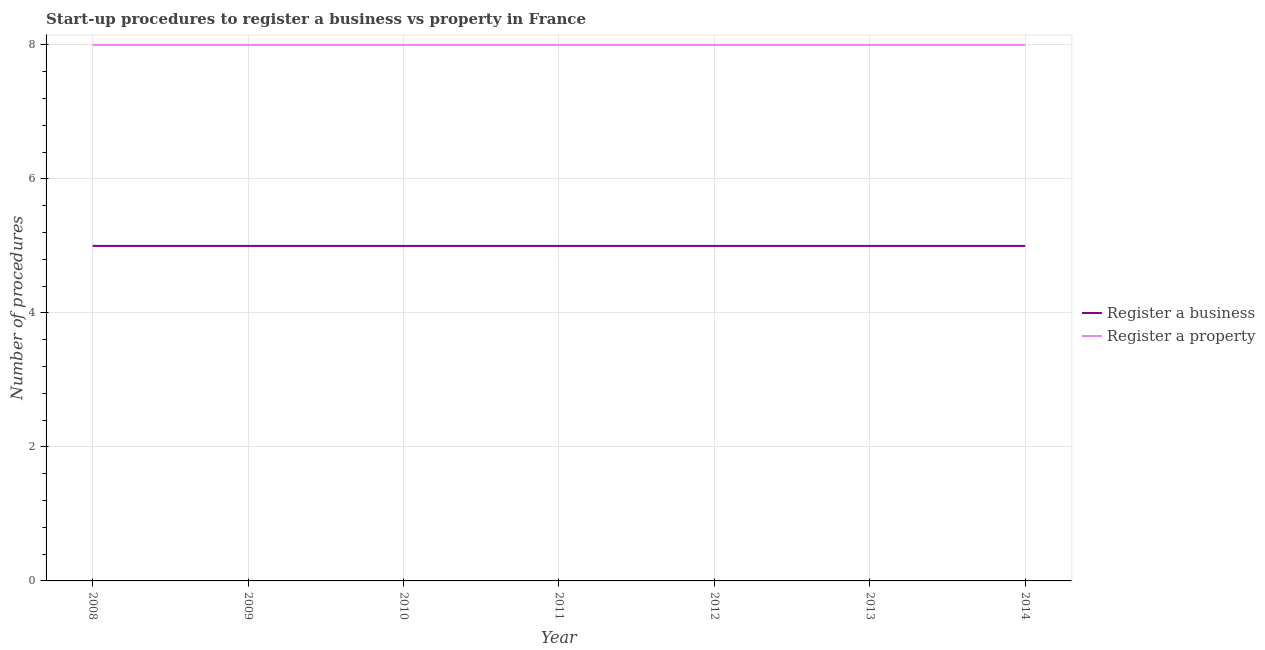Does the line corresponding to number of procedures to register a business intersect with the line corresponding to number of procedures to register a property?
Offer a very short reply. No. Is the number of lines equal to the number of legend labels?
Give a very brief answer. Yes. What is the number of procedures to register a property in 2014?
Offer a very short reply. 8. Across all years, what is the maximum number of procedures to register a property?
Give a very brief answer. 8. Across all years, what is the minimum number of procedures to register a property?
Your answer should be very brief. 8. In which year was the number of procedures to register a business maximum?
Provide a succinct answer. 2008. What is the total number of procedures to register a property in the graph?
Your answer should be very brief. 56. What is the difference between the number of procedures to register a business in 2010 and that in 2014?
Provide a short and direct response. 0. What is the difference between the number of procedures to register a business in 2013 and the number of procedures to register a property in 2014?
Make the answer very short. -3. In the year 2014, what is the difference between the number of procedures to register a business and number of procedures to register a property?
Ensure brevity in your answer.  -3. What is the ratio of the number of procedures to register a business in 2009 to that in 2011?
Ensure brevity in your answer.  1. Is the number of procedures to register a business in 2008 less than that in 2012?
Give a very brief answer. No. In how many years, is the number of procedures to register a property greater than the average number of procedures to register a property taken over all years?
Make the answer very short. 0. Is the sum of the number of procedures to register a business in 2009 and 2012 greater than the maximum number of procedures to register a property across all years?
Ensure brevity in your answer.  Yes. Does the number of procedures to register a property monotonically increase over the years?
Offer a terse response. No. Is the number of procedures to register a business strictly less than the number of procedures to register a property over the years?
Offer a very short reply. Yes. How many lines are there?
Offer a terse response. 2. How many years are there in the graph?
Give a very brief answer. 7. What is the difference between two consecutive major ticks on the Y-axis?
Make the answer very short. 2. Are the values on the major ticks of Y-axis written in scientific E-notation?
Offer a very short reply. No. Does the graph contain any zero values?
Provide a succinct answer. No. Where does the legend appear in the graph?
Offer a terse response. Center right. What is the title of the graph?
Ensure brevity in your answer.  Start-up procedures to register a business vs property in France. Does "Investment" appear as one of the legend labels in the graph?
Give a very brief answer. No. What is the label or title of the X-axis?
Ensure brevity in your answer.  Year. What is the label or title of the Y-axis?
Keep it short and to the point. Number of procedures. What is the Number of procedures in Register a business in 2008?
Your answer should be compact. 5. What is the Number of procedures of Register a property in 2008?
Give a very brief answer. 8. What is the Number of procedures of Register a business in 2009?
Provide a succinct answer. 5. What is the Number of procedures of Register a property in 2009?
Your answer should be compact. 8. What is the Number of procedures of Register a business in 2011?
Keep it short and to the point. 5. What is the Number of procedures of Register a property in 2011?
Give a very brief answer. 8. What is the Number of procedures of Register a business in 2012?
Keep it short and to the point. 5. What is the Number of procedures of Register a business in 2014?
Provide a short and direct response. 5. What is the total Number of procedures in Register a business in the graph?
Provide a short and direct response. 35. What is the total Number of procedures of Register a property in the graph?
Provide a succinct answer. 56. What is the difference between the Number of procedures of Register a business in 2008 and that in 2010?
Ensure brevity in your answer.  0. What is the difference between the Number of procedures of Register a property in 2008 and that in 2011?
Offer a very short reply. 0. What is the difference between the Number of procedures in Register a business in 2008 and that in 2012?
Ensure brevity in your answer.  0. What is the difference between the Number of procedures of Register a business in 2008 and that in 2013?
Keep it short and to the point. 0. What is the difference between the Number of procedures of Register a business in 2009 and that in 2011?
Provide a succinct answer. 0. What is the difference between the Number of procedures of Register a business in 2009 and that in 2013?
Provide a short and direct response. 0. What is the difference between the Number of procedures of Register a property in 2009 and that in 2013?
Provide a succinct answer. 0. What is the difference between the Number of procedures in Register a business in 2009 and that in 2014?
Provide a succinct answer. 0. What is the difference between the Number of procedures of Register a business in 2010 and that in 2011?
Give a very brief answer. 0. What is the difference between the Number of procedures of Register a business in 2010 and that in 2012?
Provide a short and direct response. 0. What is the difference between the Number of procedures in Register a property in 2010 and that in 2012?
Offer a very short reply. 0. What is the difference between the Number of procedures in Register a business in 2010 and that in 2013?
Provide a short and direct response. 0. What is the difference between the Number of procedures in Register a property in 2010 and that in 2013?
Give a very brief answer. 0. What is the difference between the Number of procedures of Register a property in 2011 and that in 2012?
Keep it short and to the point. 0. What is the difference between the Number of procedures of Register a business in 2012 and that in 2013?
Offer a very short reply. 0. What is the difference between the Number of procedures in Register a business in 2012 and that in 2014?
Provide a succinct answer. 0. What is the difference between the Number of procedures in Register a business in 2008 and the Number of procedures in Register a property in 2009?
Your answer should be compact. -3. What is the difference between the Number of procedures of Register a business in 2008 and the Number of procedures of Register a property in 2010?
Keep it short and to the point. -3. What is the difference between the Number of procedures in Register a business in 2008 and the Number of procedures in Register a property in 2013?
Offer a terse response. -3. What is the difference between the Number of procedures in Register a business in 2009 and the Number of procedures in Register a property in 2010?
Offer a very short reply. -3. What is the difference between the Number of procedures in Register a business in 2009 and the Number of procedures in Register a property in 2012?
Make the answer very short. -3. What is the difference between the Number of procedures in Register a business in 2010 and the Number of procedures in Register a property in 2012?
Provide a short and direct response. -3. What is the difference between the Number of procedures in Register a business in 2010 and the Number of procedures in Register a property in 2013?
Your answer should be very brief. -3. What is the difference between the Number of procedures in Register a business in 2010 and the Number of procedures in Register a property in 2014?
Give a very brief answer. -3. What is the difference between the Number of procedures of Register a business in 2011 and the Number of procedures of Register a property in 2012?
Keep it short and to the point. -3. What is the difference between the Number of procedures in Register a business in 2011 and the Number of procedures in Register a property in 2013?
Provide a succinct answer. -3. What is the difference between the Number of procedures of Register a business in 2011 and the Number of procedures of Register a property in 2014?
Provide a short and direct response. -3. What is the average Number of procedures in Register a property per year?
Offer a terse response. 8. In the year 2011, what is the difference between the Number of procedures in Register a business and Number of procedures in Register a property?
Your answer should be compact. -3. In the year 2014, what is the difference between the Number of procedures of Register a business and Number of procedures of Register a property?
Your response must be concise. -3. What is the ratio of the Number of procedures of Register a property in 2008 to that in 2010?
Your response must be concise. 1. What is the ratio of the Number of procedures in Register a business in 2008 to that in 2011?
Your response must be concise. 1. What is the ratio of the Number of procedures in Register a property in 2008 to that in 2011?
Offer a terse response. 1. What is the ratio of the Number of procedures of Register a business in 2008 to that in 2012?
Give a very brief answer. 1. What is the ratio of the Number of procedures of Register a business in 2008 to that in 2014?
Your answer should be compact. 1. What is the ratio of the Number of procedures of Register a property in 2008 to that in 2014?
Ensure brevity in your answer.  1. What is the ratio of the Number of procedures of Register a business in 2009 to that in 2010?
Provide a short and direct response. 1. What is the ratio of the Number of procedures of Register a property in 2009 to that in 2010?
Keep it short and to the point. 1. What is the ratio of the Number of procedures of Register a business in 2009 to that in 2011?
Make the answer very short. 1. What is the ratio of the Number of procedures in Register a property in 2009 to that in 2011?
Offer a terse response. 1. What is the ratio of the Number of procedures of Register a business in 2009 to that in 2012?
Keep it short and to the point. 1. What is the ratio of the Number of procedures of Register a business in 2009 to that in 2013?
Offer a very short reply. 1. What is the ratio of the Number of procedures of Register a business in 2009 to that in 2014?
Ensure brevity in your answer.  1. What is the ratio of the Number of procedures of Register a business in 2010 to that in 2011?
Make the answer very short. 1. What is the ratio of the Number of procedures in Register a property in 2010 to that in 2011?
Your response must be concise. 1. What is the ratio of the Number of procedures of Register a business in 2010 to that in 2012?
Ensure brevity in your answer.  1. What is the ratio of the Number of procedures in Register a business in 2010 to that in 2013?
Give a very brief answer. 1. What is the ratio of the Number of procedures in Register a property in 2010 to that in 2013?
Offer a terse response. 1. What is the ratio of the Number of procedures in Register a business in 2010 to that in 2014?
Provide a succinct answer. 1. What is the ratio of the Number of procedures of Register a business in 2011 to that in 2012?
Give a very brief answer. 1. What is the ratio of the Number of procedures of Register a business in 2011 to that in 2013?
Your response must be concise. 1. What is the ratio of the Number of procedures in Register a business in 2012 to that in 2013?
Ensure brevity in your answer.  1. What is the ratio of the Number of procedures in Register a property in 2012 to that in 2014?
Your answer should be very brief. 1. What is the ratio of the Number of procedures of Register a business in 2013 to that in 2014?
Your answer should be very brief. 1. What is the ratio of the Number of procedures in Register a property in 2013 to that in 2014?
Offer a terse response. 1. What is the difference between the highest and the second highest Number of procedures of Register a business?
Make the answer very short. 0. 